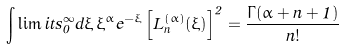<formula> <loc_0><loc_0><loc_500><loc_500>\int \lim i t s _ { 0 } ^ { \infty } d \xi \, \xi ^ { \alpha } e ^ { - \xi } \left [ L _ { n } ^ { \left ( \alpha \right ) } ( \xi ) \right ] ^ { 2 } = \frac { \Gamma ( \alpha + n + 1 ) } { n ! }</formula> 